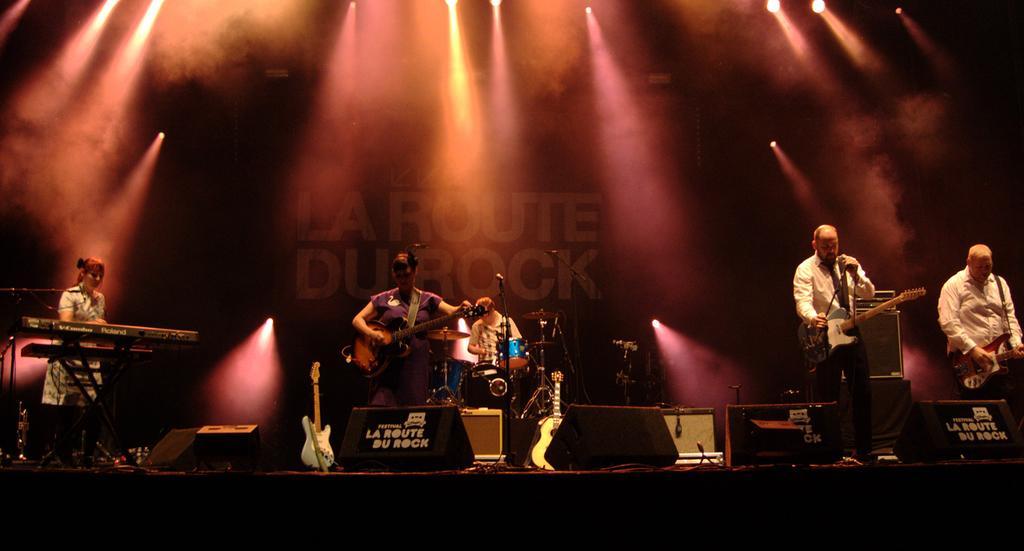Please provide a concise description of this image. In this image i can see few persons standing and holding musical instruments in their hands. In the background i can see musical instruments and a person and few lights. 